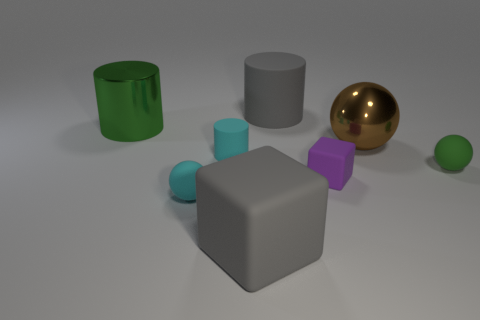The tiny rubber thing that is left of the large gray block and in front of the cyan cylinder has what shape?
Your response must be concise. Sphere. Are any brown spheres visible?
Provide a succinct answer. Yes. What material is the other big object that is the same shape as the large green shiny object?
Make the answer very short. Rubber. The shiny object that is on the right side of the small cyan rubber sphere in front of the green thing in front of the big metal cylinder is what shape?
Make the answer very short. Sphere. What number of other large rubber things are the same shape as the purple matte object?
Your answer should be very brief. 1. There is a cylinder that is behind the large metal cylinder; does it have the same color as the big object that is in front of the cyan rubber cylinder?
Your answer should be compact. Yes. There is a purple cube that is the same size as the cyan sphere; what material is it?
Your answer should be very brief. Rubber. Is there a cyan object that has the same size as the purple matte block?
Your response must be concise. Yes. Are there fewer big green shiny objects that are right of the tiny rubber cube than small blue matte cylinders?
Make the answer very short. No. Are there fewer tiny cyan things to the right of the brown object than gray cylinders on the left side of the purple block?
Offer a terse response. Yes. 